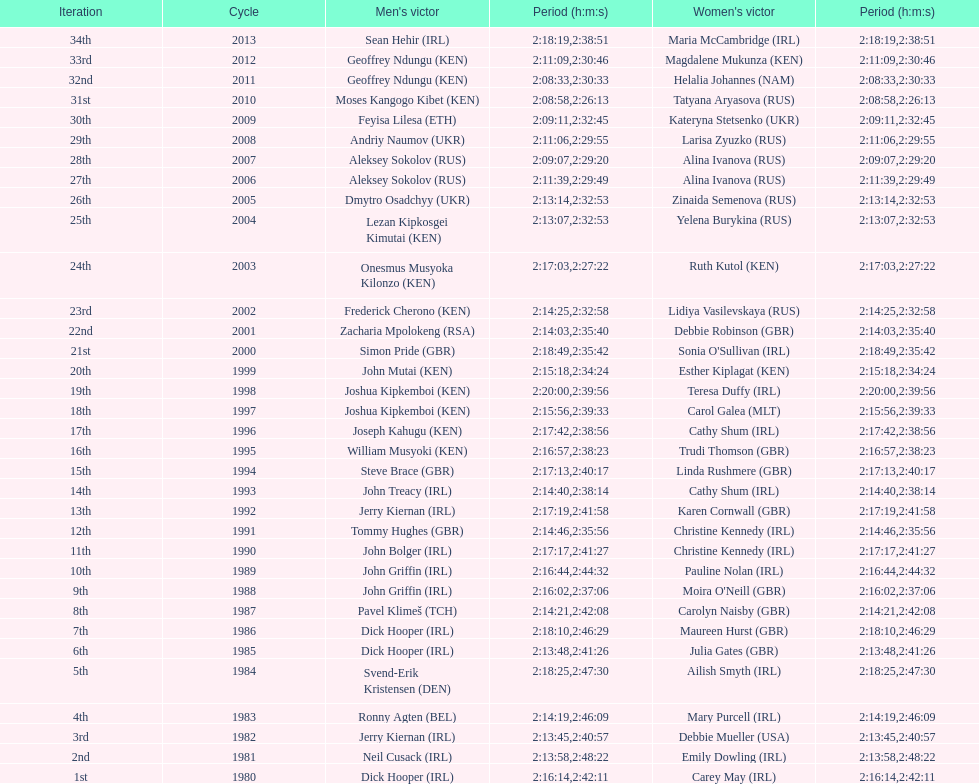Which country is represented for both men and women at the top of the list? Ireland. 